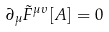<formula> <loc_0><loc_0><loc_500><loc_500>\partial _ { \mu } \tilde { F } ^ { \mu \upsilon } [ A ] = 0</formula> 